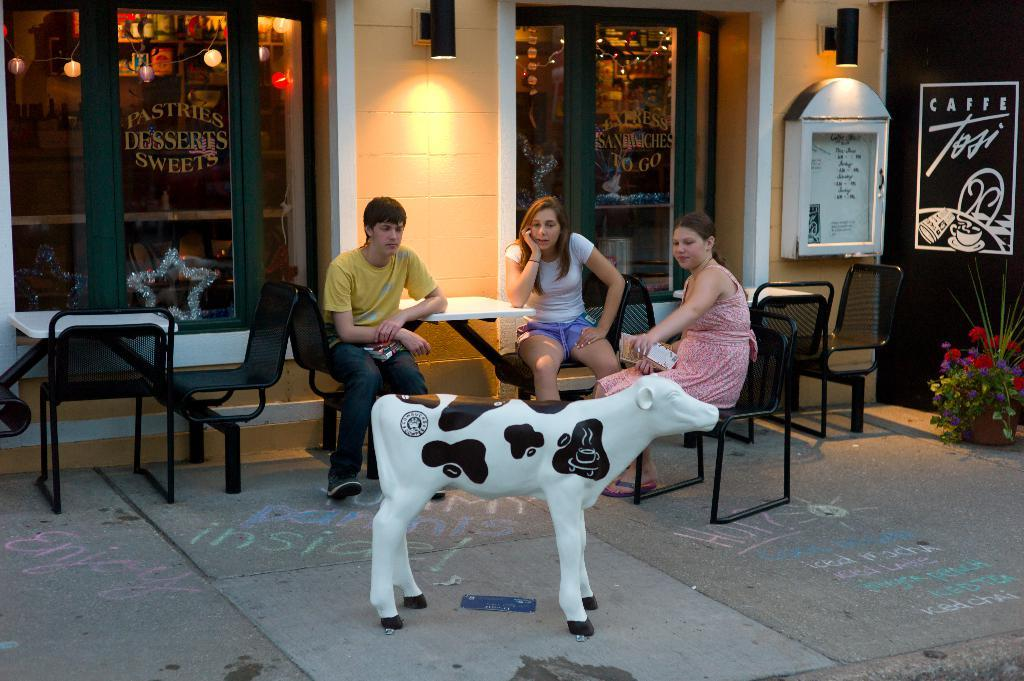How many people are in the image? There are three persons in the image. Can you describe the gender of the people in the image? One of the persons is a man, and two of the persons are women. What are the people in the image doing? The three persons are sitting on chairs. What objects are in front of the people? There is a calf and a statue in front of them. What type of guitar is the calf playing in the image? There is no guitar present in the image; it features a calf and a statue in front of the three persons sitting on chairs. 